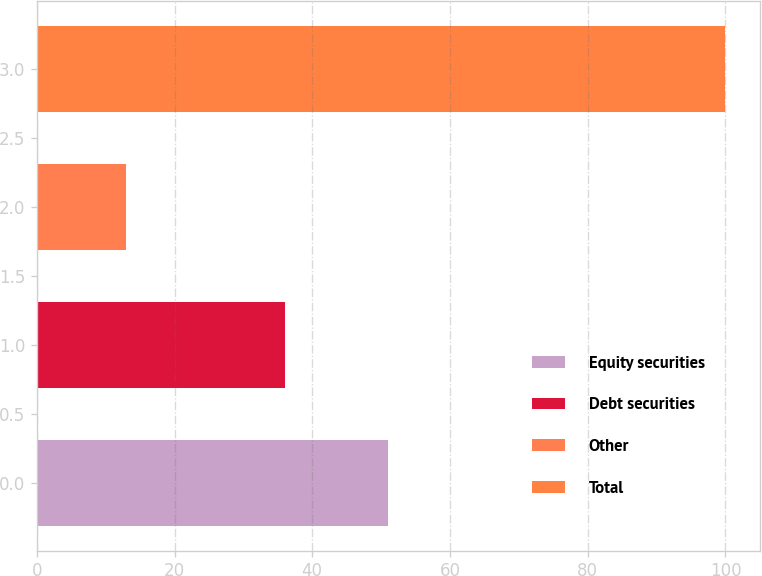Convert chart. <chart><loc_0><loc_0><loc_500><loc_500><bar_chart><fcel>Equity securities<fcel>Debt securities<fcel>Other<fcel>Total<nl><fcel>51<fcel>36<fcel>13<fcel>100<nl></chart> 